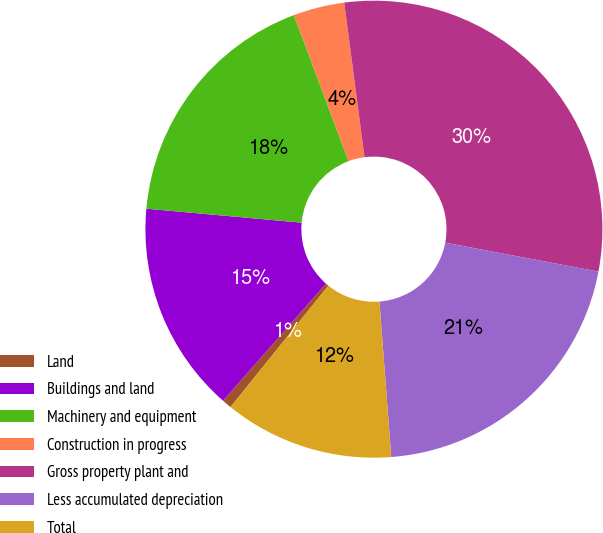<chart> <loc_0><loc_0><loc_500><loc_500><pie_chart><fcel>Land<fcel>Buildings and land<fcel>Machinery and equipment<fcel>Construction in progress<fcel>Gross property plant and<fcel>Less accumulated depreciation<fcel>Total<nl><fcel>0.68%<fcel>14.95%<fcel>17.88%<fcel>3.62%<fcel>30.05%<fcel>20.82%<fcel>12.01%<nl></chart> 